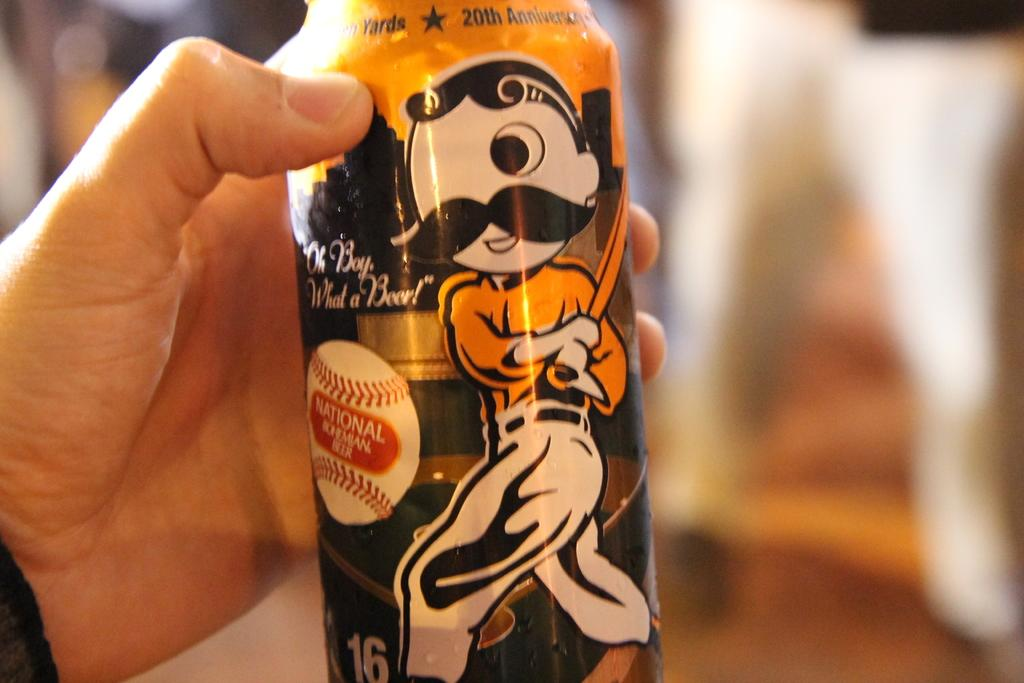What is the person's hand holding in the image? The person's hand is holding a bottle in the image. Can you describe the background of the image? The background of the image appears blurry. What can be seen on the bottle? There are pictures on the bottle. How many dimes are visible on the person's hand in the image? There are no dimes visible on the person's hand in the image. What type of debt is being discussed in the image? There is no discussion of debt in the image; it only shows a person's hand holding a bottle with pictures on it. 